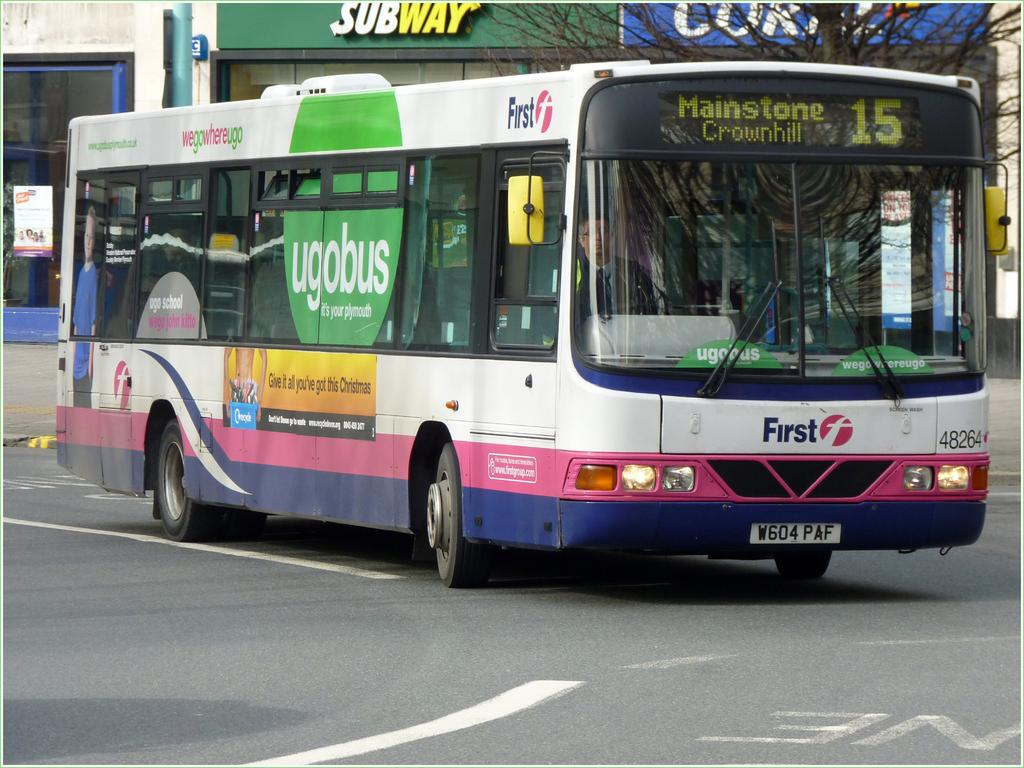<image>
Offer a succinct explanation of the picture presented. Large white, pink, and blue bus going to Mainstone Crownhill. 